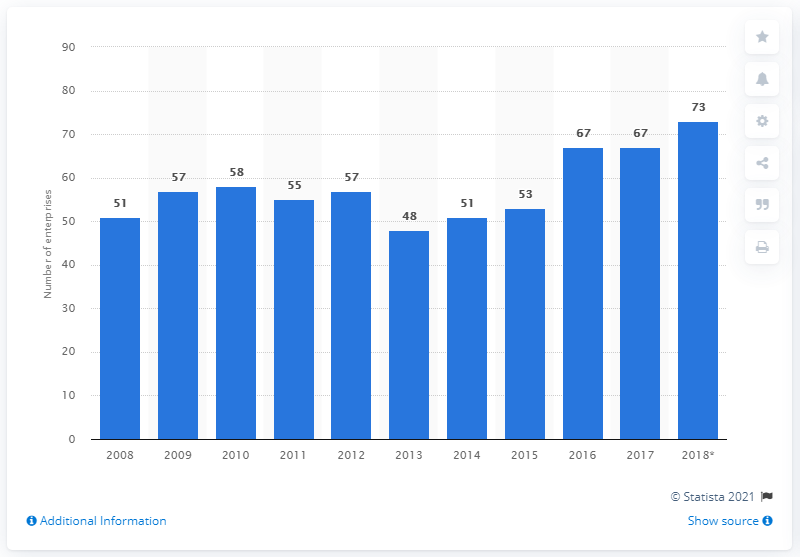Specify some key components in this picture. In Portugal in 2017, 67 companies were involved in the production of games and toys. 